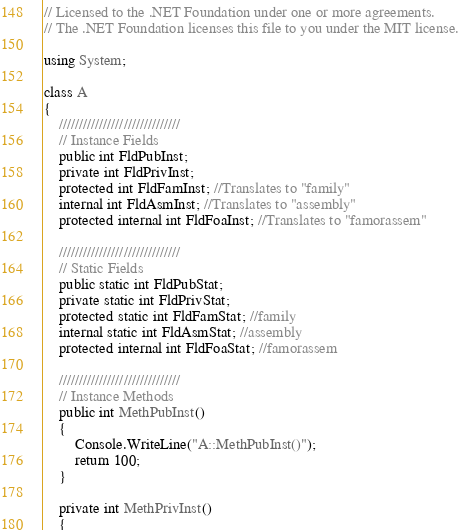Convert code to text. <code><loc_0><loc_0><loc_500><loc_500><_C#_>// Licensed to the .NET Foundation under one or more agreements.
// The .NET Foundation licenses this file to you under the MIT license.

using System;

class A
{
    //////////////////////////////
    // Instance Fields
    public int FldPubInst;
    private int FldPrivInst;
    protected int FldFamInst; //Translates to "family"
    internal int FldAsmInst; //Translates to "assembly"
    protected internal int FldFoaInst; //Translates to "famorassem"

    //////////////////////////////
    // Static Fields
    public static int FldPubStat;
    private static int FldPrivStat;
    protected static int FldFamStat; //family
    internal static int FldAsmStat; //assembly
    protected internal int FldFoaStat; //famorassem

    //////////////////////////////
    // Instance Methods
    public int MethPubInst()
    {
        Console.WriteLine("A::MethPubInst()");
        return 100;
    }

    private int MethPrivInst()
    {</code> 